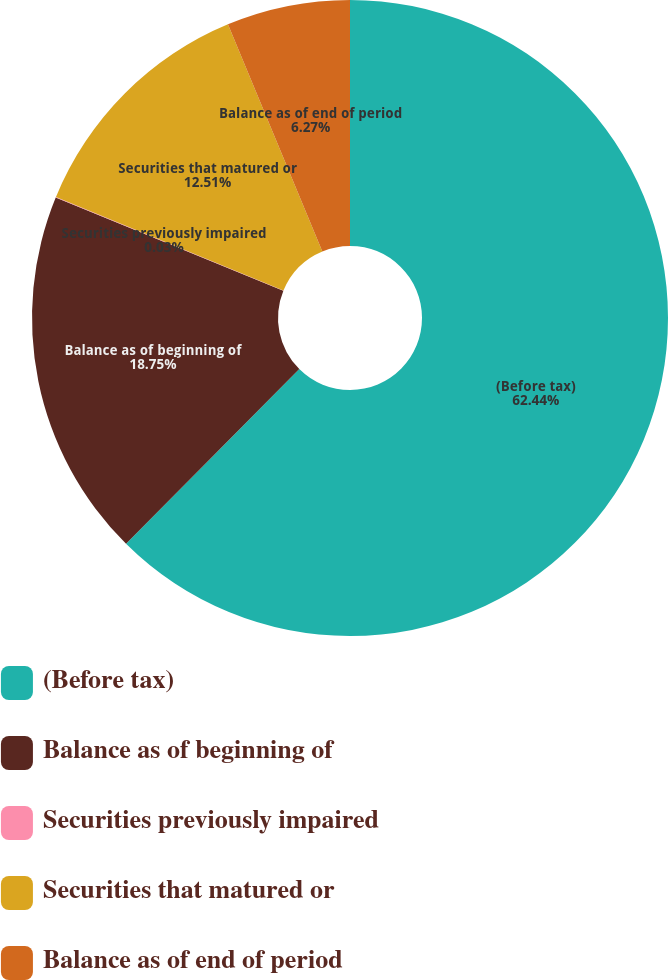Convert chart to OTSL. <chart><loc_0><loc_0><loc_500><loc_500><pie_chart><fcel>(Before tax)<fcel>Balance as of beginning of<fcel>Securities previously impaired<fcel>Securities that matured or<fcel>Balance as of end of period<nl><fcel>62.43%<fcel>18.75%<fcel>0.03%<fcel>12.51%<fcel>6.27%<nl></chart> 